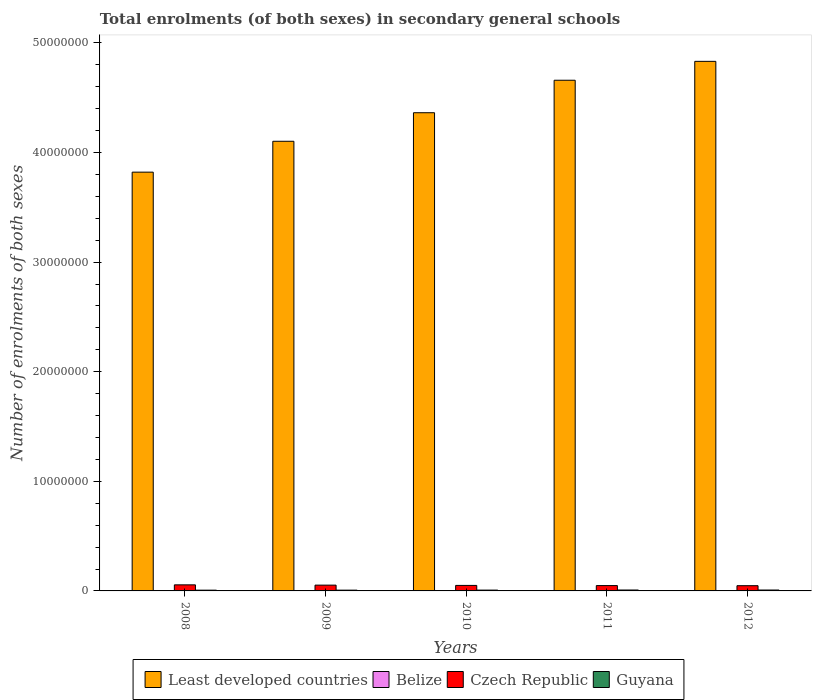How many different coloured bars are there?
Offer a terse response. 4. How many groups of bars are there?
Provide a succinct answer. 5. Are the number of bars on each tick of the X-axis equal?
Ensure brevity in your answer.  Yes. How many bars are there on the 2nd tick from the right?
Offer a terse response. 4. What is the label of the 2nd group of bars from the left?
Offer a terse response. 2009. What is the number of enrolments in secondary schools in Belize in 2009?
Your answer should be very brief. 3.04e+04. Across all years, what is the maximum number of enrolments in secondary schools in Czech Republic?
Your answer should be very brief. 5.54e+05. Across all years, what is the minimum number of enrolments in secondary schools in Czech Republic?
Provide a succinct answer. 4.77e+05. In which year was the number of enrolments in secondary schools in Czech Republic maximum?
Give a very brief answer. 2008. What is the total number of enrolments in secondary schools in Guyana in the graph?
Provide a succinct answer. 3.80e+05. What is the difference between the number of enrolments in secondary schools in Guyana in 2009 and that in 2011?
Ensure brevity in your answer.  -1.19e+04. What is the difference between the number of enrolments in secondary schools in Guyana in 2011 and the number of enrolments in secondary schools in Belize in 2012?
Offer a very short reply. 4.90e+04. What is the average number of enrolments in secondary schools in Czech Republic per year?
Give a very brief answer. 5.10e+05. In the year 2011, what is the difference between the number of enrolments in secondary schools in Least developed countries and number of enrolments in secondary schools in Guyana?
Your answer should be very brief. 4.65e+07. What is the ratio of the number of enrolments in secondary schools in Guyana in 2011 to that in 2012?
Your answer should be compact. 1.02. What is the difference between the highest and the second highest number of enrolments in secondary schools in Belize?
Offer a terse response. 1568. What is the difference between the highest and the lowest number of enrolments in secondary schools in Guyana?
Give a very brief answer. 1.31e+04. Is the sum of the number of enrolments in secondary schools in Guyana in 2009 and 2012 greater than the maximum number of enrolments in secondary schools in Czech Republic across all years?
Offer a very short reply. No. What does the 3rd bar from the left in 2011 represents?
Give a very brief answer. Czech Republic. What does the 1st bar from the right in 2008 represents?
Your answer should be very brief. Guyana. Is it the case that in every year, the sum of the number of enrolments in secondary schools in Least developed countries and number of enrolments in secondary schools in Belize is greater than the number of enrolments in secondary schools in Czech Republic?
Your answer should be very brief. Yes. How many years are there in the graph?
Make the answer very short. 5. What is the difference between two consecutive major ticks on the Y-axis?
Provide a succinct answer. 1.00e+07. Are the values on the major ticks of Y-axis written in scientific E-notation?
Make the answer very short. No. Does the graph contain any zero values?
Provide a short and direct response. No. Where does the legend appear in the graph?
Offer a terse response. Bottom center. How many legend labels are there?
Give a very brief answer. 4. What is the title of the graph?
Offer a terse response. Total enrolments (of both sexes) in secondary general schools. Does "Turkey" appear as one of the legend labels in the graph?
Ensure brevity in your answer.  No. What is the label or title of the X-axis?
Make the answer very short. Years. What is the label or title of the Y-axis?
Provide a succinct answer. Number of enrolments of both sexes. What is the Number of enrolments of both sexes in Least developed countries in 2008?
Provide a succinct answer. 3.82e+07. What is the Number of enrolments of both sexes in Belize in 2008?
Keep it short and to the point. 2.98e+04. What is the Number of enrolments of both sexes of Czech Republic in 2008?
Give a very brief answer. 5.54e+05. What is the Number of enrolments of both sexes of Guyana in 2008?
Make the answer very short. 6.96e+04. What is the Number of enrolments of both sexes of Least developed countries in 2009?
Provide a succinct answer. 4.10e+07. What is the Number of enrolments of both sexes of Belize in 2009?
Offer a terse response. 3.04e+04. What is the Number of enrolments of both sexes in Czech Republic in 2009?
Make the answer very short. 5.28e+05. What is the Number of enrolments of both sexes in Guyana in 2009?
Your answer should be very brief. 7.08e+04. What is the Number of enrolments of both sexes in Least developed countries in 2010?
Offer a very short reply. 4.36e+07. What is the Number of enrolments of both sexes in Belize in 2010?
Make the answer very short. 3.15e+04. What is the Number of enrolments of both sexes in Czech Republic in 2010?
Keep it short and to the point. 5.02e+05. What is the Number of enrolments of both sexes in Guyana in 2010?
Give a very brief answer. 7.53e+04. What is the Number of enrolments of both sexes in Least developed countries in 2011?
Ensure brevity in your answer.  4.66e+07. What is the Number of enrolments of both sexes of Belize in 2011?
Give a very brief answer. 3.21e+04. What is the Number of enrolments of both sexes in Czech Republic in 2011?
Your response must be concise. 4.87e+05. What is the Number of enrolments of both sexes in Guyana in 2011?
Your response must be concise. 8.27e+04. What is the Number of enrolments of both sexes of Least developed countries in 2012?
Ensure brevity in your answer.  4.83e+07. What is the Number of enrolments of both sexes in Belize in 2012?
Offer a very short reply. 3.37e+04. What is the Number of enrolments of both sexes in Czech Republic in 2012?
Your answer should be very brief. 4.77e+05. What is the Number of enrolments of both sexes in Guyana in 2012?
Offer a terse response. 8.14e+04. Across all years, what is the maximum Number of enrolments of both sexes in Least developed countries?
Your answer should be compact. 4.83e+07. Across all years, what is the maximum Number of enrolments of both sexes in Belize?
Provide a succinct answer. 3.37e+04. Across all years, what is the maximum Number of enrolments of both sexes of Czech Republic?
Provide a short and direct response. 5.54e+05. Across all years, what is the maximum Number of enrolments of both sexes of Guyana?
Offer a very short reply. 8.27e+04. Across all years, what is the minimum Number of enrolments of both sexes of Least developed countries?
Keep it short and to the point. 3.82e+07. Across all years, what is the minimum Number of enrolments of both sexes in Belize?
Offer a terse response. 2.98e+04. Across all years, what is the minimum Number of enrolments of both sexes in Czech Republic?
Your answer should be very brief. 4.77e+05. Across all years, what is the minimum Number of enrolments of both sexes of Guyana?
Provide a short and direct response. 6.96e+04. What is the total Number of enrolments of both sexes in Least developed countries in the graph?
Make the answer very short. 2.18e+08. What is the total Number of enrolments of both sexes in Belize in the graph?
Offer a very short reply. 1.57e+05. What is the total Number of enrolments of both sexes in Czech Republic in the graph?
Keep it short and to the point. 2.55e+06. What is the total Number of enrolments of both sexes in Guyana in the graph?
Offer a terse response. 3.80e+05. What is the difference between the Number of enrolments of both sexes of Least developed countries in 2008 and that in 2009?
Keep it short and to the point. -2.82e+06. What is the difference between the Number of enrolments of both sexes of Belize in 2008 and that in 2009?
Ensure brevity in your answer.  -598. What is the difference between the Number of enrolments of both sexes of Czech Republic in 2008 and that in 2009?
Your answer should be compact. 2.66e+04. What is the difference between the Number of enrolments of both sexes in Guyana in 2008 and that in 2009?
Give a very brief answer. -1201. What is the difference between the Number of enrolments of both sexes of Least developed countries in 2008 and that in 2010?
Provide a succinct answer. -5.42e+06. What is the difference between the Number of enrolments of both sexes in Belize in 2008 and that in 2010?
Offer a terse response. -1651. What is the difference between the Number of enrolments of both sexes of Czech Republic in 2008 and that in 2010?
Give a very brief answer. 5.22e+04. What is the difference between the Number of enrolments of both sexes in Guyana in 2008 and that in 2010?
Offer a terse response. -5715. What is the difference between the Number of enrolments of both sexes of Least developed countries in 2008 and that in 2011?
Keep it short and to the point. -8.38e+06. What is the difference between the Number of enrolments of both sexes of Belize in 2008 and that in 2011?
Ensure brevity in your answer.  -2296. What is the difference between the Number of enrolments of both sexes in Czech Republic in 2008 and that in 2011?
Make the answer very short. 6.76e+04. What is the difference between the Number of enrolments of both sexes in Guyana in 2008 and that in 2011?
Ensure brevity in your answer.  -1.31e+04. What is the difference between the Number of enrolments of both sexes of Least developed countries in 2008 and that in 2012?
Give a very brief answer. -1.01e+07. What is the difference between the Number of enrolments of both sexes in Belize in 2008 and that in 2012?
Ensure brevity in your answer.  -3864. What is the difference between the Number of enrolments of both sexes in Czech Republic in 2008 and that in 2012?
Offer a very short reply. 7.71e+04. What is the difference between the Number of enrolments of both sexes of Guyana in 2008 and that in 2012?
Provide a succinct answer. -1.18e+04. What is the difference between the Number of enrolments of both sexes in Least developed countries in 2009 and that in 2010?
Offer a very short reply. -2.60e+06. What is the difference between the Number of enrolments of both sexes in Belize in 2009 and that in 2010?
Ensure brevity in your answer.  -1053. What is the difference between the Number of enrolments of both sexes of Czech Republic in 2009 and that in 2010?
Keep it short and to the point. 2.56e+04. What is the difference between the Number of enrolments of both sexes in Guyana in 2009 and that in 2010?
Your answer should be compact. -4514. What is the difference between the Number of enrolments of both sexes in Least developed countries in 2009 and that in 2011?
Provide a short and direct response. -5.57e+06. What is the difference between the Number of enrolments of both sexes of Belize in 2009 and that in 2011?
Give a very brief answer. -1698. What is the difference between the Number of enrolments of both sexes in Czech Republic in 2009 and that in 2011?
Offer a terse response. 4.10e+04. What is the difference between the Number of enrolments of both sexes in Guyana in 2009 and that in 2011?
Provide a succinct answer. -1.19e+04. What is the difference between the Number of enrolments of both sexes of Least developed countries in 2009 and that in 2012?
Ensure brevity in your answer.  -7.29e+06. What is the difference between the Number of enrolments of both sexes of Belize in 2009 and that in 2012?
Ensure brevity in your answer.  -3266. What is the difference between the Number of enrolments of both sexes of Czech Republic in 2009 and that in 2012?
Your answer should be very brief. 5.05e+04. What is the difference between the Number of enrolments of both sexes in Guyana in 2009 and that in 2012?
Ensure brevity in your answer.  -1.06e+04. What is the difference between the Number of enrolments of both sexes of Least developed countries in 2010 and that in 2011?
Provide a succinct answer. -2.96e+06. What is the difference between the Number of enrolments of both sexes of Belize in 2010 and that in 2011?
Ensure brevity in your answer.  -645. What is the difference between the Number of enrolments of both sexes in Czech Republic in 2010 and that in 2011?
Your response must be concise. 1.54e+04. What is the difference between the Number of enrolments of both sexes in Guyana in 2010 and that in 2011?
Your answer should be compact. -7391. What is the difference between the Number of enrolments of both sexes in Least developed countries in 2010 and that in 2012?
Keep it short and to the point. -4.69e+06. What is the difference between the Number of enrolments of both sexes of Belize in 2010 and that in 2012?
Provide a succinct answer. -2213. What is the difference between the Number of enrolments of both sexes of Czech Republic in 2010 and that in 2012?
Provide a short and direct response. 2.48e+04. What is the difference between the Number of enrolments of both sexes in Guyana in 2010 and that in 2012?
Provide a short and direct response. -6059. What is the difference between the Number of enrolments of both sexes of Least developed countries in 2011 and that in 2012?
Your answer should be very brief. -1.72e+06. What is the difference between the Number of enrolments of both sexes in Belize in 2011 and that in 2012?
Provide a succinct answer. -1568. What is the difference between the Number of enrolments of both sexes of Czech Republic in 2011 and that in 2012?
Provide a short and direct response. 9439. What is the difference between the Number of enrolments of both sexes of Guyana in 2011 and that in 2012?
Give a very brief answer. 1332. What is the difference between the Number of enrolments of both sexes of Least developed countries in 2008 and the Number of enrolments of both sexes of Belize in 2009?
Your response must be concise. 3.82e+07. What is the difference between the Number of enrolments of both sexes in Least developed countries in 2008 and the Number of enrolments of both sexes in Czech Republic in 2009?
Offer a very short reply. 3.77e+07. What is the difference between the Number of enrolments of both sexes in Least developed countries in 2008 and the Number of enrolments of both sexes in Guyana in 2009?
Offer a terse response. 3.81e+07. What is the difference between the Number of enrolments of both sexes of Belize in 2008 and the Number of enrolments of both sexes of Czech Republic in 2009?
Make the answer very short. -4.98e+05. What is the difference between the Number of enrolments of both sexes of Belize in 2008 and the Number of enrolments of both sexes of Guyana in 2009?
Your answer should be compact. -4.10e+04. What is the difference between the Number of enrolments of both sexes in Czech Republic in 2008 and the Number of enrolments of both sexes in Guyana in 2009?
Make the answer very short. 4.84e+05. What is the difference between the Number of enrolments of both sexes of Least developed countries in 2008 and the Number of enrolments of both sexes of Belize in 2010?
Offer a terse response. 3.82e+07. What is the difference between the Number of enrolments of both sexes of Least developed countries in 2008 and the Number of enrolments of both sexes of Czech Republic in 2010?
Your response must be concise. 3.77e+07. What is the difference between the Number of enrolments of both sexes in Least developed countries in 2008 and the Number of enrolments of both sexes in Guyana in 2010?
Ensure brevity in your answer.  3.81e+07. What is the difference between the Number of enrolments of both sexes of Belize in 2008 and the Number of enrolments of both sexes of Czech Republic in 2010?
Provide a succinct answer. -4.72e+05. What is the difference between the Number of enrolments of both sexes of Belize in 2008 and the Number of enrolments of both sexes of Guyana in 2010?
Provide a short and direct response. -4.55e+04. What is the difference between the Number of enrolments of both sexes in Czech Republic in 2008 and the Number of enrolments of both sexes in Guyana in 2010?
Give a very brief answer. 4.79e+05. What is the difference between the Number of enrolments of both sexes of Least developed countries in 2008 and the Number of enrolments of both sexes of Belize in 2011?
Your answer should be compact. 3.82e+07. What is the difference between the Number of enrolments of both sexes in Least developed countries in 2008 and the Number of enrolments of both sexes in Czech Republic in 2011?
Keep it short and to the point. 3.77e+07. What is the difference between the Number of enrolments of both sexes in Least developed countries in 2008 and the Number of enrolments of both sexes in Guyana in 2011?
Give a very brief answer. 3.81e+07. What is the difference between the Number of enrolments of both sexes of Belize in 2008 and the Number of enrolments of both sexes of Czech Republic in 2011?
Give a very brief answer. -4.57e+05. What is the difference between the Number of enrolments of both sexes of Belize in 2008 and the Number of enrolments of both sexes of Guyana in 2011?
Offer a very short reply. -5.29e+04. What is the difference between the Number of enrolments of both sexes of Czech Republic in 2008 and the Number of enrolments of both sexes of Guyana in 2011?
Provide a succinct answer. 4.72e+05. What is the difference between the Number of enrolments of both sexes in Least developed countries in 2008 and the Number of enrolments of both sexes in Belize in 2012?
Provide a succinct answer. 3.82e+07. What is the difference between the Number of enrolments of both sexes of Least developed countries in 2008 and the Number of enrolments of both sexes of Czech Republic in 2012?
Ensure brevity in your answer.  3.77e+07. What is the difference between the Number of enrolments of both sexes of Least developed countries in 2008 and the Number of enrolments of both sexes of Guyana in 2012?
Give a very brief answer. 3.81e+07. What is the difference between the Number of enrolments of both sexes in Belize in 2008 and the Number of enrolments of both sexes in Czech Republic in 2012?
Offer a terse response. -4.48e+05. What is the difference between the Number of enrolments of both sexes in Belize in 2008 and the Number of enrolments of both sexes in Guyana in 2012?
Keep it short and to the point. -5.16e+04. What is the difference between the Number of enrolments of both sexes of Czech Republic in 2008 and the Number of enrolments of both sexes of Guyana in 2012?
Keep it short and to the point. 4.73e+05. What is the difference between the Number of enrolments of both sexes in Least developed countries in 2009 and the Number of enrolments of both sexes in Belize in 2010?
Give a very brief answer. 4.10e+07. What is the difference between the Number of enrolments of both sexes in Least developed countries in 2009 and the Number of enrolments of both sexes in Czech Republic in 2010?
Offer a terse response. 4.05e+07. What is the difference between the Number of enrolments of both sexes of Least developed countries in 2009 and the Number of enrolments of both sexes of Guyana in 2010?
Your answer should be very brief. 4.09e+07. What is the difference between the Number of enrolments of both sexes of Belize in 2009 and the Number of enrolments of both sexes of Czech Republic in 2010?
Keep it short and to the point. -4.72e+05. What is the difference between the Number of enrolments of both sexes in Belize in 2009 and the Number of enrolments of both sexes in Guyana in 2010?
Your response must be concise. -4.49e+04. What is the difference between the Number of enrolments of both sexes of Czech Republic in 2009 and the Number of enrolments of both sexes of Guyana in 2010?
Make the answer very short. 4.52e+05. What is the difference between the Number of enrolments of both sexes of Least developed countries in 2009 and the Number of enrolments of both sexes of Belize in 2011?
Your answer should be very brief. 4.10e+07. What is the difference between the Number of enrolments of both sexes of Least developed countries in 2009 and the Number of enrolments of both sexes of Czech Republic in 2011?
Your response must be concise. 4.05e+07. What is the difference between the Number of enrolments of both sexes of Least developed countries in 2009 and the Number of enrolments of both sexes of Guyana in 2011?
Provide a short and direct response. 4.09e+07. What is the difference between the Number of enrolments of both sexes of Belize in 2009 and the Number of enrolments of both sexes of Czech Republic in 2011?
Offer a terse response. -4.56e+05. What is the difference between the Number of enrolments of both sexes in Belize in 2009 and the Number of enrolments of both sexes in Guyana in 2011?
Offer a terse response. -5.23e+04. What is the difference between the Number of enrolments of both sexes of Czech Republic in 2009 and the Number of enrolments of both sexes of Guyana in 2011?
Offer a very short reply. 4.45e+05. What is the difference between the Number of enrolments of both sexes in Least developed countries in 2009 and the Number of enrolments of both sexes in Belize in 2012?
Keep it short and to the point. 4.10e+07. What is the difference between the Number of enrolments of both sexes of Least developed countries in 2009 and the Number of enrolments of both sexes of Czech Republic in 2012?
Your answer should be compact. 4.05e+07. What is the difference between the Number of enrolments of both sexes of Least developed countries in 2009 and the Number of enrolments of both sexes of Guyana in 2012?
Provide a short and direct response. 4.09e+07. What is the difference between the Number of enrolments of both sexes in Belize in 2009 and the Number of enrolments of both sexes in Czech Republic in 2012?
Make the answer very short. -4.47e+05. What is the difference between the Number of enrolments of both sexes in Belize in 2009 and the Number of enrolments of both sexes in Guyana in 2012?
Offer a very short reply. -5.10e+04. What is the difference between the Number of enrolments of both sexes of Czech Republic in 2009 and the Number of enrolments of both sexes of Guyana in 2012?
Offer a terse response. 4.46e+05. What is the difference between the Number of enrolments of both sexes of Least developed countries in 2010 and the Number of enrolments of both sexes of Belize in 2011?
Provide a short and direct response. 4.36e+07. What is the difference between the Number of enrolments of both sexes of Least developed countries in 2010 and the Number of enrolments of both sexes of Czech Republic in 2011?
Provide a short and direct response. 4.31e+07. What is the difference between the Number of enrolments of both sexes in Least developed countries in 2010 and the Number of enrolments of both sexes in Guyana in 2011?
Ensure brevity in your answer.  4.35e+07. What is the difference between the Number of enrolments of both sexes of Belize in 2010 and the Number of enrolments of both sexes of Czech Republic in 2011?
Offer a very short reply. -4.55e+05. What is the difference between the Number of enrolments of both sexes in Belize in 2010 and the Number of enrolments of both sexes in Guyana in 2011?
Your answer should be compact. -5.13e+04. What is the difference between the Number of enrolments of both sexes in Czech Republic in 2010 and the Number of enrolments of both sexes in Guyana in 2011?
Offer a very short reply. 4.19e+05. What is the difference between the Number of enrolments of both sexes of Least developed countries in 2010 and the Number of enrolments of both sexes of Belize in 2012?
Give a very brief answer. 4.36e+07. What is the difference between the Number of enrolments of both sexes of Least developed countries in 2010 and the Number of enrolments of both sexes of Czech Republic in 2012?
Offer a terse response. 4.32e+07. What is the difference between the Number of enrolments of both sexes of Least developed countries in 2010 and the Number of enrolments of both sexes of Guyana in 2012?
Provide a short and direct response. 4.35e+07. What is the difference between the Number of enrolments of both sexes in Belize in 2010 and the Number of enrolments of both sexes in Czech Republic in 2012?
Give a very brief answer. -4.46e+05. What is the difference between the Number of enrolments of both sexes in Belize in 2010 and the Number of enrolments of both sexes in Guyana in 2012?
Your response must be concise. -4.99e+04. What is the difference between the Number of enrolments of both sexes of Czech Republic in 2010 and the Number of enrolments of both sexes of Guyana in 2012?
Make the answer very short. 4.21e+05. What is the difference between the Number of enrolments of both sexes in Least developed countries in 2011 and the Number of enrolments of both sexes in Belize in 2012?
Offer a terse response. 4.66e+07. What is the difference between the Number of enrolments of both sexes of Least developed countries in 2011 and the Number of enrolments of both sexes of Czech Republic in 2012?
Ensure brevity in your answer.  4.61e+07. What is the difference between the Number of enrolments of both sexes in Least developed countries in 2011 and the Number of enrolments of both sexes in Guyana in 2012?
Ensure brevity in your answer.  4.65e+07. What is the difference between the Number of enrolments of both sexes in Belize in 2011 and the Number of enrolments of both sexes in Czech Republic in 2012?
Ensure brevity in your answer.  -4.45e+05. What is the difference between the Number of enrolments of both sexes of Belize in 2011 and the Number of enrolments of both sexes of Guyana in 2012?
Offer a terse response. -4.93e+04. What is the difference between the Number of enrolments of both sexes in Czech Republic in 2011 and the Number of enrolments of both sexes in Guyana in 2012?
Provide a succinct answer. 4.05e+05. What is the average Number of enrolments of both sexes of Least developed countries per year?
Your answer should be very brief. 4.36e+07. What is the average Number of enrolments of both sexes in Belize per year?
Your answer should be very brief. 3.15e+04. What is the average Number of enrolments of both sexes in Czech Republic per year?
Offer a terse response. 5.10e+05. What is the average Number of enrolments of both sexes in Guyana per year?
Keep it short and to the point. 7.60e+04. In the year 2008, what is the difference between the Number of enrolments of both sexes in Least developed countries and Number of enrolments of both sexes in Belize?
Provide a short and direct response. 3.82e+07. In the year 2008, what is the difference between the Number of enrolments of both sexes of Least developed countries and Number of enrolments of both sexes of Czech Republic?
Ensure brevity in your answer.  3.77e+07. In the year 2008, what is the difference between the Number of enrolments of both sexes in Least developed countries and Number of enrolments of both sexes in Guyana?
Offer a terse response. 3.81e+07. In the year 2008, what is the difference between the Number of enrolments of both sexes of Belize and Number of enrolments of both sexes of Czech Republic?
Provide a succinct answer. -5.25e+05. In the year 2008, what is the difference between the Number of enrolments of both sexes in Belize and Number of enrolments of both sexes in Guyana?
Provide a short and direct response. -3.98e+04. In the year 2008, what is the difference between the Number of enrolments of both sexes of Czech Republic and Number of enrolments of both sexes of Guyana?
Give a very brief answer. 4.85e+05. In the year 2009, what is the difference between the Number of enrolments of both sexes in Least developed countries and Number of enrolments of both sexes in Belize?
Offer a very short reply. 4.10e+07. In the year 2009, what is the difference between the Number of enrolments of both sexes in Least developed countries and Number of enrolments of both sexes in Czech Republic?
Offer a terse response. 4.05e+07. In the year 2009, what is the difference between the Number of enrolments of both sexes of Least developed countries and Number of enrolments of both sexes of Guyana?
Your answer should be very brief. 4.10e+07. In the year 2009, what is the difference between the Number of enrolments of both sexes in Belize and Number of enrolments of both sexes in Czech Republic?
Make the answer very short. -4.97e+05. In the year 2009, what is the difference between the Number of enrolments of both sexes in Belize and Number of enrolments of both sexes in Guyana?
Offer a very short reply. -4.04e+04. In the year 2009, what is the difference between the Number of enrolments of both sexes of Czech Republic and Number of enrolments of both sexes of Guyana?
Provide a succinct answer. 4.57e+05. In the year 2010, what is the difference between the Number of enrolments of both sexes of Least developed countries and Number of enrolments of both sexes of Belize?
Provide a succinct answer. 4.36e+07. In the year 2010, what is the difference between the Number of enrolments of both sexes in Least developed countries and Number of enrolments of both sexes in Czech Republic?
Give a very brief answer. 4.31e+07. In the year 2010, what is the difference between the Number of enrolments of both sexes of Least developed countries and Number of enrolments of both sexes of Guyana?
Offer a terse response. 4.36e+07. In the year 2010, what is the difference between the Number of enrolments of both sexes of Belize and Number of enrolments of both sexes of Czech Republic?
Keep it short and to the point. -4.71e+05. In the year 2010, what is the difference between the Number of enrolments of both sexes in Belize and Number of enrolments of both sexes in Guyana?
Keep it short and to the point. -4.39e+04. In the year 2010, what is the difference between the Number of enrolments of both sexes of Czech Republic and Number of enrolments of both sexes of Guyana?
Offer a very short reply. 4.27e+05. In the year 2011, what is the difference between the Number of enrolments of both sexes in Least developed countries and Number of enrolments of both sexes in Belize?
Make the answer very short. 4.66e+07. In the year 2011, what is the difference between the Number of enrolments of both sexes in Least developed countries and Number of enrolments of both sexes in Czech Republic?
Provide a succinct answer. 4.61e+07. In the year 2011, what is the difference between the Number of enrolments of both sexes in Least developed countries and Number of enrolments of both sexes in Guyana?
Offer a terse response. 4.65e+07. In the year 2011, what is the difference between the Number of enrolments of both sexes of Belize and Number of enrolments of both sexes of Czech Republic?
Offer a terse response. -4.55e+05. In the year 2011, what is the difference between the Number of enrolments of both sexes in Belize and Number of enrolments of both sexes in Guyana?
Offer a very short reply. -5.06e+04. In the year 2011, what is the difference between the Number of enrolments of both sexes of Czech Republic and Number of enrolments of both sexes of Guyana?
Make the answer very short. 4.04e+05. In the year 2012, what is the difference between the Number of enrolments of both sexes of Least developed countries and Number of enrolments of both sexes of Belize?
Provide a short and direct response. 4.83e+07. In the year 2012, what is the difference between the Number of enrolments of both sexes of Least developed countries and Number of enrolments of both sexes of Czech Republic?
Make the answer very short. 4.78e+07. In the year 2012, what is the difference between the Number of enrolments of both sexes in Least developed countries and Number of enrolments of both sexes in Guyana?
Offer a very short reply. 4.82e+07. In the year 2012, what is the difference between the Number of enrolments of both sexes of Belize and Number of enrolments of both sexes of Czech Republic?
Ensure brevity in your answer.  -4.44e+05. In the year 2012, what is the difference between the Number of enrolments of both sexes in Belize and Number of enrolments of both sexes in Guyana?
Ensure brevity in your answer.  -4.77e+04. In the year 2012, what is the difference between the Number of enrolments of both sexes in Czech Republic and Number of enrolments of both sexes in Guyana?
Your answer should be very brief. 3.96e+05. What is the ratio of the Number of enrolments of both sexes in Least developed countries in 2008 to that in 2009?
Provide a succinct answer. 0.93. What is the ratio of the Number of enrolments of both sexes of Belize in 2008 to that in 2009?
Your response must be concise. 0.98. What is the ratio of the Number of enrolments of both sexes in Czech Republic in 2008 to that in 2009?
Make the answer very short. 1.05. What is the ratio of the Number of enrolments of both sexes of Least developed countries in 2008 to that in 2010?
Provide a succinct answer. 0.88. What is the ratio of the Number of enrolments of both sexes of Belize in 2008 to that in 2010?
Offer a terse response. 0.95. What is the ratio of the Number of enrolments of both sexes of Czech Republic in 2008 to that in 2010?
Offer a very short reply. 1.1. What is the ratio of the Number of enrolments of both sexes of Guyana in 2008 to that in 2010?
Your answer should be compact. 0.92. What is the ratio of the Number of enrolments of both sexes of Least developed countries in 2008 to that in 2011?
Offer a terse response. 0.82. What is the ratio of the Number of enrolments of both sexes of Belize in 2008 to that in 2011?
Your answer should be very brief. 0.93. What is the ratio of the Number of enrolments of both sexes in Czech Republic in 2008 to that in 2011?
Keep it short and to the point. 1.14. What is the ratio of the Number of enrolments of both sexes of Guyana in 2008 to that in 2011?
Ensure brevity in your answer.  0.84. What is the ratio of the Number of enrolments of both sexes of Least developed countries in 2008 to that in 2012?
Your answer should be very brief. 0.79. What is the ratio of the Number of enrolments of both sexes of Belize in 2008 to that in 2012?
Keep it short and to the point. 0.89. What is the ratio of the Number of enrolments of both sexes in Czech Republic in 2008 to that in 2012?
Offer a very short reply. 1.16. What is the ratio of the Number of enrolments of both sexes of Guyana in 2008 to that in 2012?
Offer a very short reply. 0.86. What is the ratio of the Number of enrolments of both sexes of Least developed countries in 2009 to that in 2010?
Provide a short and direct response. 0.94. What is the ratio of the Number of enrolments of both sexes of Belize in 2009 to that in 2010?
Your answer should be very brief. 0.97. What is the ratio of the Number of enrolments of both sexes in Czech Republic in 2009 to that in 2010?
Your response must be concise. 1.05. What is the ratio of the Number of enrolments of both sexes of Guyana in 2009 to that in 2010?
Give a very brief answer. 0.94. What is the ratio of the Number of enrolments of both sexes in Least developed countries in 2009 to that in 2011?
Make the answer very short. 0.88. What is the ratio of the Number of enrolments of both sexes in Belize in 2009 to that in 2011?
Ensure brevity in your answer.  0.95. What is the ratio of the Number of enrolments of both sexes in Czech Republic in 2009 to that in 2011?
Offer a terse response. 1.08. What is the ratio of the Number of enrolments of both sexes in Guyana in 2009 to that in 2011?
Your answer should be compact. 0.86. What is the ratio of the Number of enrolments of both sexes in Least developed countries in 2009 to that in 2012?
Keep it short and to the point. 0.85. What is the ratio of the Number of enrolments of both sexes of Belize in 2009 to that in 2012?
Offer a very short reply. 0.9. What is the ratio of the Number of enrolments of both sexes in Czech Republic in 2009 to that in 2012?
Offer a terse response. 1.11. What is the ratio of the Number of enrolments of both sexes of Guyana in 2009 to that in 2012?
Give a very brief answer. 0.87. What is the ratio of the Number of enrolments of both sexes of Least developed countries in 2010 to that in 2011?
Provide a succinct answer. 0.94. What is the ratio of the Number of enrolments of both sexes in Belize in 2010 to that in 2011?
Your answer should be compact. 0.98. What is the ratio of the Number of enrolments of both sexes of Czech Republic in 2010 to that in 2011?
Keep it short and to the point. 1.03. What is the ratio of the Number of enrolments of both sexes of Guyana in 2010 to that in 2011?
Provide a short and direct response. 0.91. What is the ratio of the Number of enrolments of both sexes of Least developed countries in 2010 to that in 2012?
Provide a succinct answer. 0.9. What is the ratio of the Number of enrolments of both sexes of Belize in 2010 to that in 2012?
Give a very brief answer. 0.93. What is the ratio of the Number of enrolments of both sexes in Czech Republic in 2010 to that in 2012?
Offer a very short reply. 1.05. What is the ratio of the Number of enrolments of both sexes in Guyana in 2010 to that in 2012?
Provide a succinct answer. 0.93. What is the ratio of the Number of enrolments of both sexes in Belize in 2011 to that in 2012?
Offer a terse response. 0.95. What is the ratio of the Number of enrolments of both sexes in Czech Republic in 2011 to that in 2012?
Keep it short and to the point. 1.02. What is the ratio of the Number of enrolments of both sexes of Guyana in 2011 to that in 2012?
Offer a very short reply. 1.02. What is the difference between the highest and the second highest Number of enrolments of both sexes of Least developed countries?
Offer a terse response. 1.72e+06. What is the difference between the highest and the second highest Number of enrolments of both sexes in Belize?
Make the answer very short. 1568. What is the difference between the highest and the second highest Number of enrolments of both sexes of Czech Republic?
Provide a succinct answer. 2.66e+04. What is the difference between the highest and the second highest Number of enrolments of both sexes of Guyana?
Provide a succinct answer. 1332. What is the difference between the highest and the lowest Number of enrolments of both sexes of Least developed countries?
Provide a short and direct response. 1.01e+07. What is the difference between the highest and the lowest Number of enrolments of both sexes of Belize?
Offer a very short reply. 3864. What is the difference between the highest and the lowest Number of enrolments of both sexes in Czech Republic?
Your response must be concise. 7.71e+04. What is the difference between the highest and the lowest Number of enrolments of both sexes in Guyana?
Your answer should be compact. 1.31e+04. 